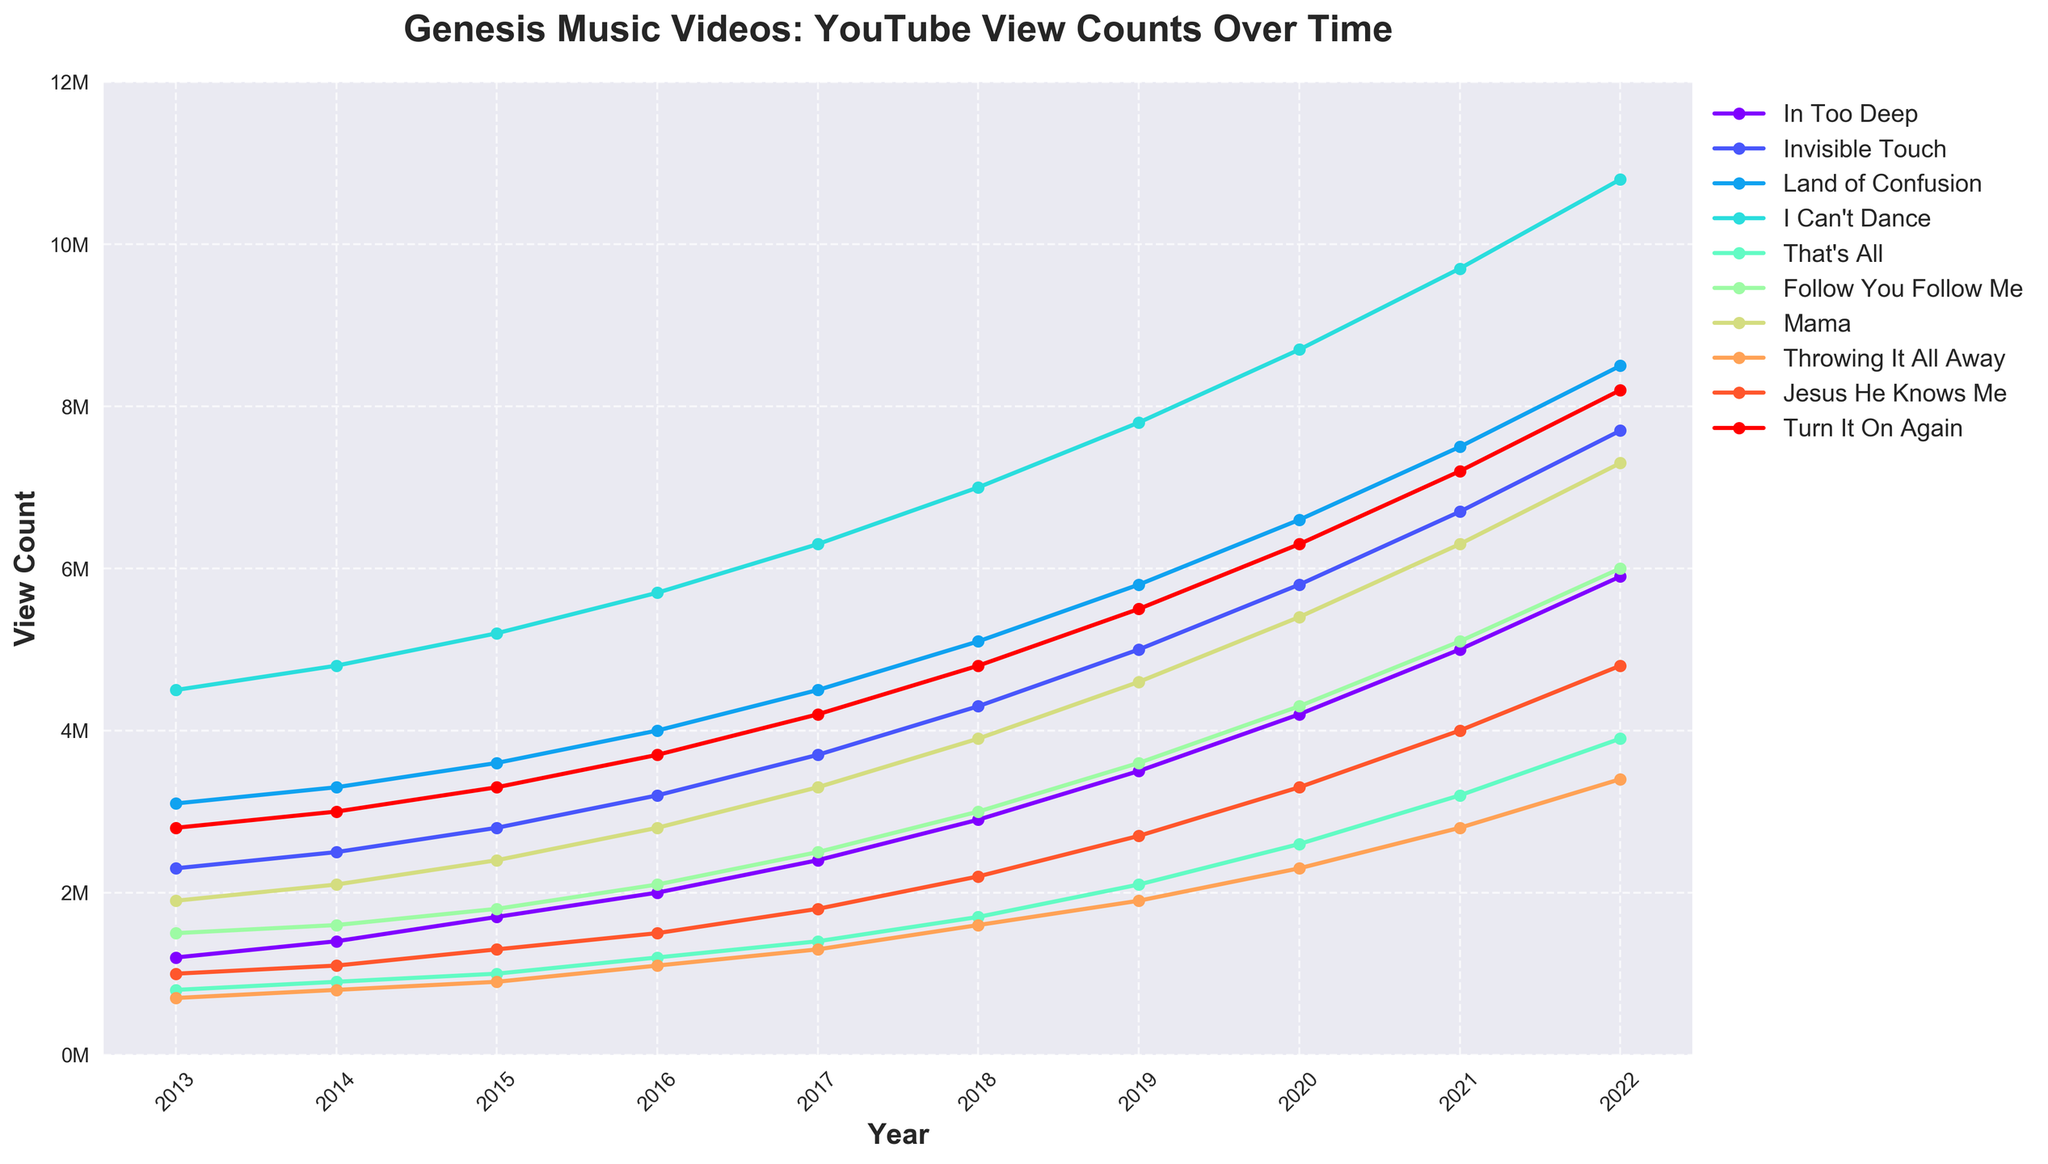what is the total view count for "Invisible Touch" for the entire decade? Sum the view counts of "Invisible Touch" from 2013 to 2022: 2,300,000 + 2,500,000 + 2,800,000 + 3,200,000 + 3,700,000 + 4,300,000 + 5,000,000 + 5,800,000 + 6,700,000 + 7,700,000 = 43,000,000
Answer: 43,000,000 Which music video had the highest increase in view count between 2013 and 2022? Calculate the difference in view count for each video between 2013 and 2022, then identify the video with the largest increase: (In Too Deep: 4,700,000, Invisible Touch: 5,400,000, Land of Confusion: 5,400,000, I Can't Dance: 6,300,000, That's All: 3,100,000, Follow You Follow Me: 4,500,000, Mama: 5,400,000, Throwing It All Away: 2,700,000, Jesus He Knows Me: 3,800,000, Turn It On Again: 5,400,000)
Answer: I Can't Dance In which year did "Turn It On Again" surpass the 5 million view count? Check the yearly view counts for "Turn It On Again" and identify the first year it exceeds 5,000,000: It has values 2,800,000 (2013), 3,000,000 (2014), 3,300,000 (2015), 3,700,000 (2016), 4,200,000 (2017), 4,800,000 (2018), 5,500,000 (2019), 6,300,000 (2020), 7,200,000 (2021), and 8,200,000 (2022)
Answer: 2019 What is the average view count for "Mama" from 2013 to 2022? Sum the view counts from 2013 to 2022 and divide by the number of years: (1,900,000 + 2,100,000 + 2,400,000 + 2,800,000 + 3,300,000 + 3,900,000 + 4,600,000 + 5,400,000 + 6,300,000 + 7,300,000) / 10 = 40,000,000 / 10
Answer: 4,000,000 By 2022, which music video has the second highest view count? Compare the view counts for all videos in 2022 and identify the video with the second-highest value: (In Too Deep: 5,900,000, Invisible Touch: 7,700,000, Land of Confusion: 8,500,000, I Can't Dance: 10,800,000, That's All: 3,900,000, Follow You Follow Me: 6,000,000, Mama: 7,300,000, Throwing It All Away: 3,400,000, Jesus He Knows Me: 4,800,000, Turn It On Again: 8,200,000)
Answer: Land of Confusion Which years did "I Can't Dance" surpass 7 million views? Identify the years in which "I Can't Dance" crossed 7 million: It has values 4,500,000 (2013), 4,800,000 (2014), 5,200,000 (2015), 5,700,000 (2016), 6,300,000 (2017), 7,000,000 (2018), 7,800,000 (2019), 8,700,000 (2020), 9,700,000 (2021), 10,800,000 (2022)
Answer: 2018-2022 